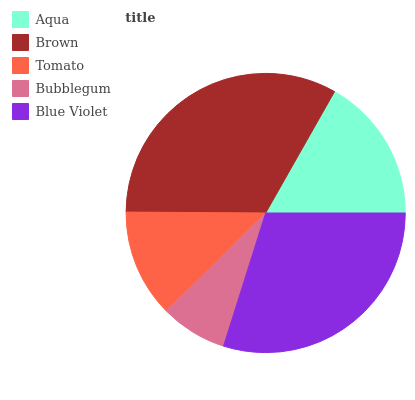Is Bubblegum the minimum?
Answer yes or no. Yes. Is Brown the maximum?
Answer yes or no. Yes. Is Tomato the minimum?
Answer yes or no. No. Is Tomato the maximum?
Answer yes or no. No. Is Brown greater than Tomato?
Answer yes or no. Yes. Is Tomato less than Brown?
Answer yes or no. Yes. Is Tomato greater than Brown?
Answer yes or no. No. Is Brown less than Tomato?
Answer yes or no. No. Is Aqua the high median?
Answer yes or no. Yes. Is Aqua the low median?
Answer yes or no. Yes. Is Blue Violet the high median?
Answer yes or no. No. Is Tomato the low median?
Answer yes or no. No. 